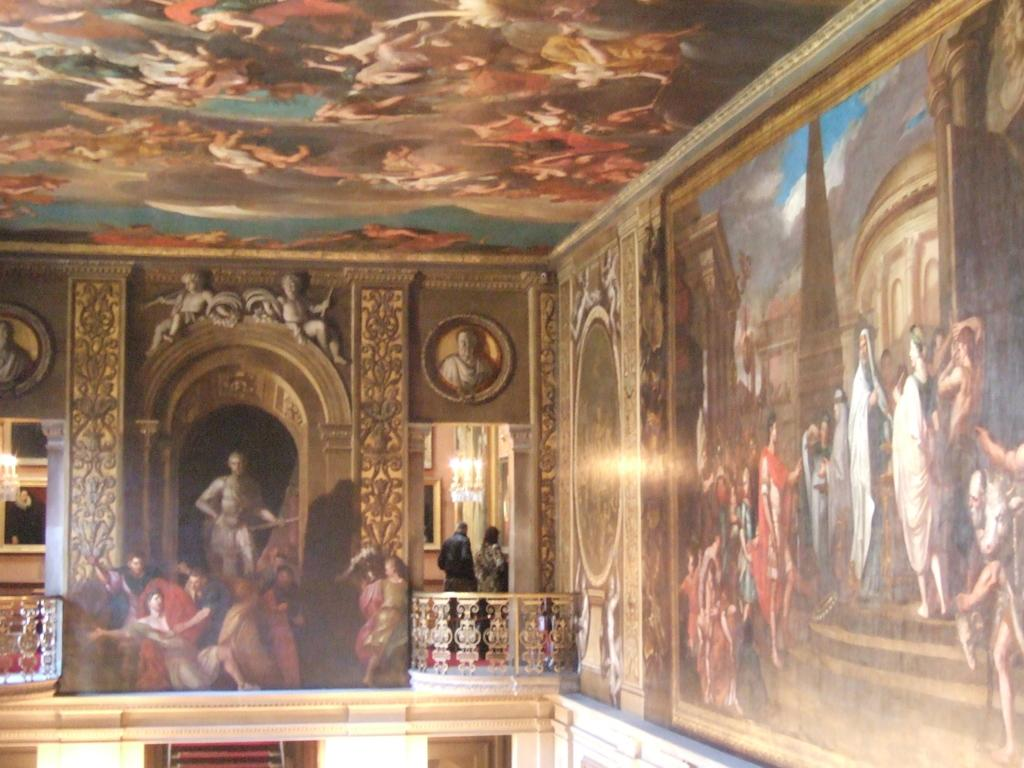What type of structure is visible in the image? There is a building in the image. What can be seen on the wall inside the building? There are paintings on a wall in the image. Are there any people present in the image? Yes, there are persons standing in the image. What type of barrier is present in the image? There is a fencing in the image. What can be used to illuminate the area in the image? There are lights in the image. Is there any decorative element on the wall in the image? Yes, there is a wall with a photo frame in the image. What type of fruit is the son holding in the image? There is no son or fruit present in the image. What type of mask is the person wearing in the image? There is no mask present in the image. 